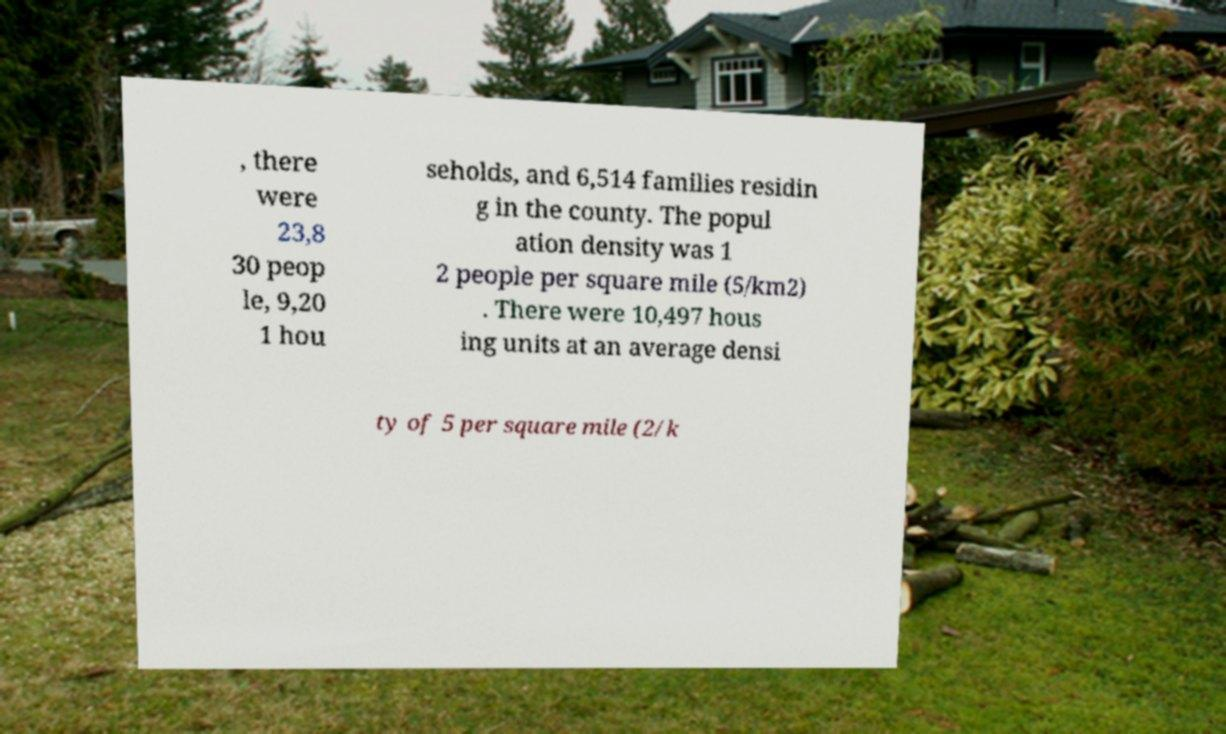Could you extract and type out the text from this image? , there were 23,8 30 peop le, 9,20 1 hou seholds, and 6,514 families residin g in the county. The popul ation density was 1 2 people per square mile (5/km2) . There were 10,497 hous ing units at an average densi ty of 5 per square mile (2/k 